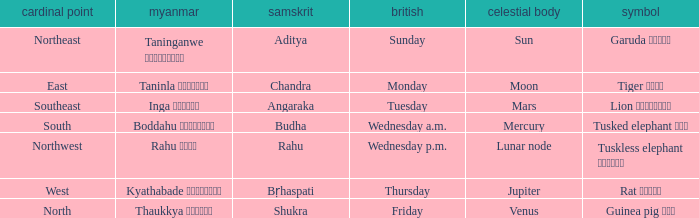What is the Burmese term associated with a cardinal direction of west? Kyathabade ကြာသပတေး. 